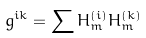<formula> <loc_0><loc_0><loc_500><loc_500>\bar { g } ^ { i k } = \sum \bar { H } _ { m } ^ { ( i ) } \bar { H } _ { m } ^ { ( k ) }</formula> 